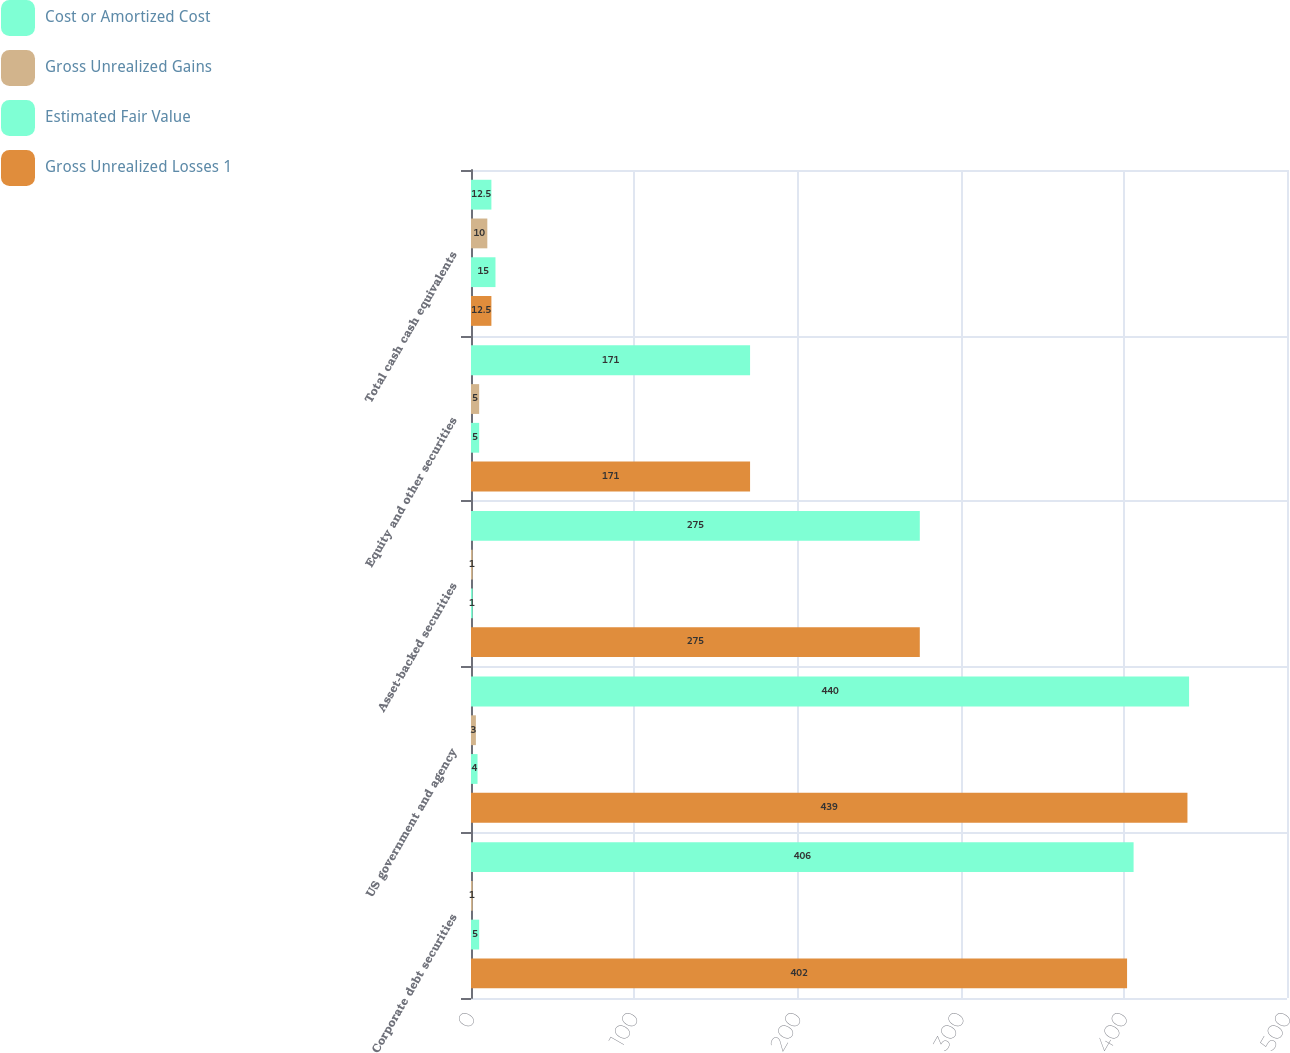Convert chart. <chart><loc_0><loc_0><loc_500><loc_500><stacked_bar_chart><ecel><fcel>Corporate debt securities<fcel>US government and agency<fcel>Asset-backed securities<fcel>Equity and other securities<fcel>Total cash cash equivalents<nl><fcel>Cost or Amortized Cost<fcel>406<fcel>440<fcel>275<fcel>171<fcel>12.5<nl><fcel>Gross Unrealized Gains<fcel>1<fcel>3<fcel>1<fcel>5<fcel>10<nl><fcel>Estimated Fair Value<fcel>5<fcel>4<fcel>1<fcel>5<fcel>15<nl><fcel>Gross Unrealized Losses 1<fcel>402<fcel>439<fcel>275<fcel>171<fcel>12.5<nl></chart> 